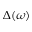<formula> <loc_0><loc_0><loc_500><loc_500>\Delta ( \omega )</formula> 